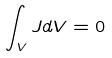Convert formula to latex. <formula><loc_0><loc_0><loc_500><loc_500>\int _ { V } J d V = 0</formula> 